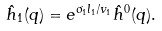<formula> <loc_0><loc_0><loc_500><loc_500>\hat { h } _ { 1 } ( q ) = e ^ { \sigma _ { 1 } l _ { 1 } / v _ { 1 } } \hat { h } ^ { 0 } ( q ) .</formula> 